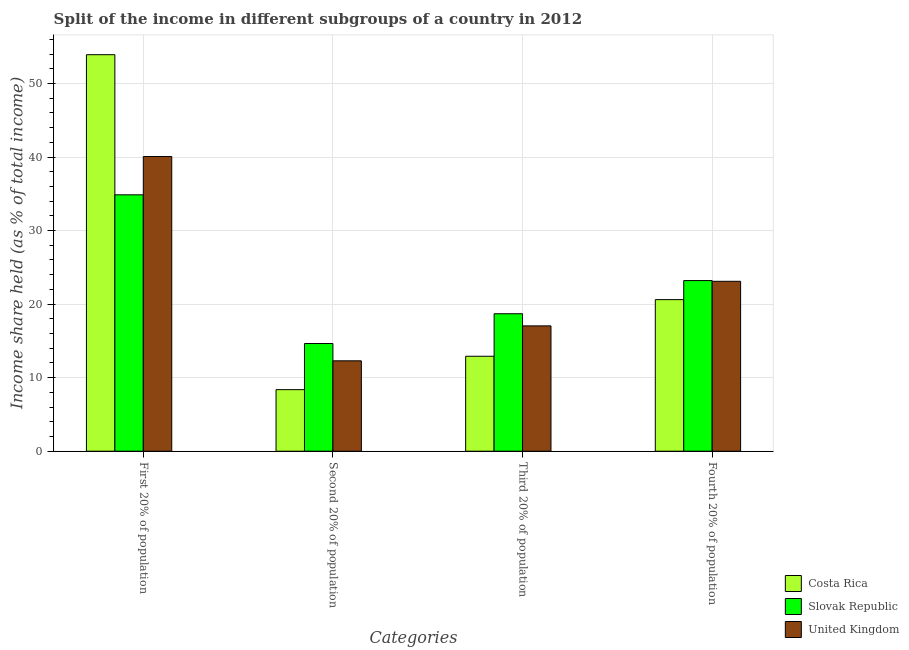How many different coloured bars are there?
Provide a short and direct response. 3. What is the label of the 2nd group of bars from the left?
Your answer should be compact. Second 20% of population. What is the share of the income held by first 20% of the population in Costa Rica?
Your response must be concise. 53.91. Across all countries, what is the maximum share of the income held by third 20% of the population?
Your answer should be very brief. 18.69. Across all countries, what is the minimum share of the income held by first 20% of the population?
Your response must be concise. 34.86. In which country was the share of the income held by third 20% of the population maximum?
Your answer should be compact. Slovak Republic. What is the total share of the income held by second 20% of the population in the graph?
Your response must be concise. 35.3. What is the difference between the share of the income held by first 20% of the population in Slovak Republic and that in Costa Rica?
Your answer should be very brief. -19.05. What is the difference between the share of the income held by second 20% of the population in Costa Rica and the share of the income held by first 20% of the population in United Kingdom?
Ensure brevity in your answer.  -31.7. What is the average share of the income held by second 20% of the population per country?
Your answer should be compact. 11.77. What is the difference between the share of the income held by fourth 20% of the population and share of the income held by first 20% of the population in Costa Rica?
Keep it short and to the point. -33.3. What is the ratio of the share of the income held by first 20% of the population in Slovak Republic to that in United Kingdom?
Keep it short and to the point. 0.87. Is the difference between the share of the income held by fourth 20% of the population in United Kingdom and Slovak Republic greater than the difference between the share of the income held by third 20% of the population in United Kingdom and Slovak Republic?
Ensure brevity in your answer.  Yes. What is the difference between the highest and the second highest share of the income held by fourth 20% of the population?
Your response must be concise. 0.1. What is the difference between the highest and the lowest share of the income held by fourth 20% of the population?
Offer a terse response. 2.59. Is the sum of the share of the income held by fourth 20% of the population in Slovak Republic and United Kingdom greater than the maximum share of the income held by second 20% of the population across all countries?
Offer a terse response. Yes. Is it the case that in every country, the sum of the share of the income held by first 20% of the population and share of the income held by third 20% of the population is greater than the sum of share of the income held by fourth 20% of the population and share of the income held by second 20% of the population?
Offer a terse response. Yes. What does the 2nd bar from the left in Third 20% of population represents?
Your answer should be compact. Slovak Republic. Is it the case that in every country, the sum of the share of the income held by first 20% of the population and share of the income held by second 20% of the population is greater than the share of the income held by third 20% of the population?
Your answer should be compact. Yes. How many bars are there?
Give a very brief answer. 12. Are the values on the major ticks of Y-axis written in scientific E-notation?
Offer a very short reply. No. Where does the legend appear in the graph?
Provide a short and direct response. Bottom right. What is the title of the graph?
Give a very brief answer. Split of the income in different subgroups of a country in 2012. What is the label or title of the X-axis?
Offer a very short reply. Categories. What is the label or title of the Y-axis?
Your answer should be very brief. Income share held (as % of total income). What is the Income share held (as % of total income) in Costa Rica in First 20% of population?
Give a very brief answer. 53.91. What is the Income share held (as % of total income) in Slovak Republic in First 20% of population?
Offer a terse response. 34.86. What is the Income share held (as % of total income) of United Kingdom in First 20% of population?
Give a very brief answer. 40.07. What is the Income share held (as % of total income) of Costa Rica in Second 20% of population?
Your response must be concise. 8.37. What is the Income share held (as % of total income) of Slovak Republic in Second 20% of population?
Keep it short and to the point. 14.64. What is the Income share held (as % of total income) in United Kingdom in Second 20% of population?
Your response must be concise. 12.29. What is the Income share held (as % of total income) of Costa Rica in Third 20% of population?
Ensure brevity in your answer.  12.91. What is the Income share held (as % of total income) in Slovak Republic in Third 20% of population?
Offer a terse response. 18.69. What is the Income share held (as % of total income) in United Kingdom in Third 20% of population?
Provide a succinct answer. 17.04. What is the Income share held (as % of total income) in Costa Rica in Fourth 20% of population?
Make the answer very short. 20.61. What is the Income share held (as % of total income) in Slovak Republic in Fourth 20% of population?
Give a very brief answer. 23.2. What is the Income share held (as % of total income) of United Kingdom in Fourth 20% of population?
Your answer should be compact. 23.1. Across all Categories, what is the maximum Income share held (as % of total income) of Costa Rica?
Provide a succinct answer. 53.91. Across all Categories, what is the maximum Income share held (as % of total income) in Slovak Republic?
Your answer should be very brief. 34.86. Across all Categories, what is the maximum Income share held (as % of total income) of United Kingdom?
Provide a short and direct response. 40.07. Across all Categories, what is the minimum Income share held (as % of total income) of Costa Rica?
Your response must be concise. 8.37. Across all Categories, what is the minimum Income share held (as % of total income) in Slovak Republic?
Provide a succinct answer. 14.64. Across all Categories, what is the minimum Income share held (as % of total income) in United Kingdom?
Your answer should be compact. 12.29. What is the total Income share held (as % of total income) of Costa Rica in the graph?
Your response must be concise. 95.8. What is the total Income share held (as % of total income) of Slovak Republic in the graph?
Ensure brevity in your answer.  91.39. What is the total Income share held (as % of total income) in United Kingdom in the graph?
Your answer should be compact. 92.5. What is the difference between the Income share held (as % of total income) of Costa Rica in First 20% of population and that in Second 20% of population?
Keep it short and to the point. 45.54. What is the difference between the Income share held (as % of total income) of Slovak Republic in First 20% of population and that in Second 20% of population?
Give a very brief answer. 20.22. What is the difference between the Income share held (as % of total income) in United Kingdom in First 20% of population and that in Second 20% of population?
Your answer should be compact. 27.78. What is the difference between the Income share held (as % of total income) of Costa Rica in First 20% of population and that in Third 20% of population?
Keep it short and to the point. 41. What is the difference between the Income share held (as % of total income) in Slovak Republic in First 20% of population and that in Third 20% of population?
Ensure brevity in your answer.  16.17. What is the difference between the Income share held (as % of total income) in United Kingdom in First 20% of population and that in Third 20% of population?
Your answer should be very brief. 23.03. What is the difference between the Income share held (as % of total income) of Costa Rica in First 20% of population and that in Fourth 20% of population?
Ensure brevity in your answer.  33.3. What is the difference between the Income share held (as % of total income) in Slovak Republic in First 20% of population and that in Fourth 20% of population?
Your answer should be compact. 11.66. What is the difference between the Income share held (as % of total income) in United Kingdom in First 20% of population and that in Fourth 20% of population?
Keep it short and to the point. 16.97. What is the difference between the Income share held (as % of total income) in Costa Rica in Second 20% of population and that in Third 20% of population?
Ensure brevity in your answer.  -4.54. What is the difference between the Income share held (as % of total income) of Slovak Republic in Second 20% of population and that in Third 20% of population?
Your response must be concise. -4.05. What is the difference between the Income share held (as % of total income) in United Kingdom in Second 20% of population and that in Third 20% of population?
Keep it short and to the point. -4.75. What is the difference between the Income share held (as % of total income) in Costa Rica in Second 20% of population and that in Fourth 20% of population?
Your answer should be very brief. -12.24. What is the difference between the Income share held (as % of total income) in Slovak Republic in Second 20% of population and that in Fourth 20% of population?
Your answer should be compact. -8.56. What is the difference between the Income share held (as % of total income) in United Kingdom in Second 20% of population and that in Fourth 20% of population?
Offer a terse response. -10.81. What is the difference between the Income share held (as % of total income) of Costa Rica in Third 20% of population and that in Fourth 20% of population?
Your response must be concise. -7.7. What is the difference between the Income share held (as % of total income) of Slovak Republic in Third 20% of population and that in Fourth 20% of population?
Offer a terse response. -4.51. What is the difference between the Income share held (as % of total income) in United Kingdom in Third 20% of population and that in Fourth 20% of population?
Provide a succinct answer. -6.06. What is the difference between the Income share held (as % of total income) of Costa Rica in First 20% of population and the Income share held (as % of total income) of Slovak Republic in Second 20% of population?
Offer a terse response. 39.27. What is the difference between the Income share held (as % of total income) of Costa Rica in First 20% of population and the Income share held (as % of total income) of United Kingdom in Second 20% of population?
Provide a short and direct response. 41.62. What is the difference between the Income share held (as % of total income) of Slovak Republic in First 20% of population and the Income share held (as % of total income) of United Kingdom in Second 20% of population?
Offer a very short reply. 22.57. What is the difference between the Income share held (as % of total income) of Costa Rica in First 20% of population and the Income share held (as % of total income) of Slovak Republic in Third 20% of population?
Your answer should be compact. 35.22. What is the difference between the Income share held (as % of total income) of Costa Rica in First 20% of population and the Income share held (as % of total income) of United Kingdom in Third 20% of population?
Offer a terse response. 36.87. What is the difference between the Income share held (as % of total income) in Slovak Republic in First 20% of population and the Income share held (as % of total income) in United Kingdom in Third 20% of population?
Your answer should be very brief. 17.82. What is the difference between the Income share held (as % of total income) of Costa Rica in First 20% of population and the Income share held (as % of total income) of Slovak Republic in Fourth 20% of population?
Provide a succinct answer. 30.71. What is the difference between the Income share held (as % of total income) of Costa Rica in First 20% of population and the Income share held (as % of total income) of United Kingdom in Fourth 20% of population?
Ensure brevity in your answer.  30.81. What is the difference between the Income share held (as % of total income) in Slovak Republic in First 20% of population and the Income share held (as % of total income) in United Kingdom in Fourth 20% of population?
Offer a terse response. 11.76. What is the difference between the Income share held (as % of total income) of Costa Rica in Second 20% of population and the Income share held (as % of total income) of Slovak Republic in Third 20% of population?
Offer a very short reply. -10.32. What is the difference between the Income share held (as % of total income) of Costa Rica in Second 20% of population and the Income share held (as % of total income) of United Kingdom in Third 20% of population?
Provide a succinct answer. -8.67. What is the difference between the Income share held (as % of total income) of Slovak Republic in Second 20% of population and the Income share held (as % of total income) of United Kingdom in Third 20% of population?
Make the answer very short. -2.4. What is the difference between the Income share held (as % of total income) of Costa Rica in Second 20% of population and the Income share held (as % of total income) of Slovak Republic in Fourth 20% of population?
Ensure brevity in your answer.  -14.83. What is the difference between the Income share held (as % of total income) of Costa Rica in Second 20% of population and the Income share held (as % of total income) of United Kingdom in Fourth 20% of population?
Make the answer very short. -14.73. What is the difference between the Income share held (as % of total income) in Slovak Republic in Second 20% of population and the Income share held (as % of total income) in United Kingdom in Fourth 20% of population?
Keep it short and to the point. -8.46. What is the difference between the Income share held (as % of total income) of Costa Rica in Third 20% of population and the Income share held (as % of total income) of Slovak Republic in Fourth 20% of population?
Make the answer very short. -10.29. What is the difference between the Income share held (as % of total income) in Costa Rica in Third 20% of population and the Income share held (as % of total income) in United Kingdom in Fourth 20% of population?
Your response must be concise. -10.19. What is the difference between the Income share held (as % of total income) in Slovak Republic in Third 20% of population and the Income share held (as % of total income) in United Kingdom in Fourth 20% of population?
Offer a terse response. -4.41. What is the average Income share held (as % of total income) of Costa Rica per Categories?
Your answer should be very brief. 23.95. What is the average Income share held (as % of total income) in Slovak Republic per Categories?
Offer a very short reply. 22.85. What is the average Income share held (as % of total income) in United Kingdom per Categories?
Your answer should be very brief. 23.12. What is the difference between the Income share held (as % of total income) of Costa Rica and Income share held (as % of total income) of Slovak Republic in First 20% of population?
Give a very brief answer. 19.05. What is the difference between the Income share held (as % of total income) of Costa Rica and Income share held (as % of total income) of United Kingdom in First 20% of population?
Give a very brief answer. 13.84. What is the difference between the Income share held (as % of total income) in Slovak Republic and Income share held (as % of total income) in United Kingdom in First 20% of population?
Provide a short and direct response. -5.21. What is the difference between the Income share held (as % of total income) in Costa Rica and Income share held (as % of total income) in Slovak Republic in Second 20% of population?
Make the answer very short. -6.27. What is the difference between the Income share held (as % of total income) in Costa Rica and Income share held (as % of total income) in United Kingdom in Second 20% of population?
Your response must be concise. -3.92. What is the difference between the Income share held (as % of total income) of Slovak Republic and Income share held (as % of total income) of United Kingdom in Second 20% of population?
Offer a very short reply. 2.35. What is the difference between the Income share held (as % of total income) of Costa Rica and Income share held (as % of total income) of Slovak Republic in Third 20% of population?
Give a very brief answer. -5.78. What is the difference between the Income share held (as % of total income) in Costa Rica and Income share held (as % of total income) in United Kingdom in Third 20% of population?
Provide a succinct answer. -4.13. What is the difference between the Income share held (as % of total income) of Slovak Republic and Income share held (as % of total income) of United Kingdom in Third 20% of population?
Make the answer very short. 1.65. What is the difference between the Income share held (as % of total income) of Costa Rica and Income share held (as % of total income) of Slovak Republic in Fourth 20% of population?
Your response must be concise. -2.59. What is the difference between the Income share held (as % of total income) in Costa Rica and Income share held (as % of total income) in United Kingdom in Fourth 20% of population?
Offer a terse response. -2.49. What is the ratio of the Income share held (as % of total income) of Costa Rica in First 20% of population to that in Second 20% of population?
Provide a short and direct response. 6.44. What is the ratio of the Income share held (as % of total income) of Slovak Republic in First 20% of population to that in Second 20% of population?
Offer a very short reply. 2.38. What is the ratio of the Income share held (as % of total income) of United Kingdom in First 20% of population to that in Second 20% of population?
Your response must be concise. 3.26. What is the ratio of the Income share held (as % of total income) of Costa Rica in First 20% of population to that in Third 20% of population?
Provide a succinct answer. 4.18. What is the ratio of the Income share held (as % of total income) in Slovak Republic in First 20% of population to that in Third 20% of population?
Provide a succinct answer. 1.87. What is the ratio of the Income share held (as % of total income) in United Kingdom in First 20% of population to that in Third 20% of population?
Give a very brief answer. 2.35. What is the ratio of the Income share held (as % of total income) in Costa Rica in First 20% of population to that in Fourth 20% of population?
Offer a terse response. 2.62. What is the ratio of the Income share held (as % of total income) of Slovak Republic in First 20% of population to that in Fourth 20% of population?
Your answer should be compact. 1.5. What is the ratio of the Income share held (as % of total income) in United Kingdom in First 20% of population to that in Fourth 20% of population?
Provide a short and direct response. 1.73. What is the ratio of the Income share held (as % of total income) of Costa Rica in Second 20% of population to that in Third 20% of population?
Provide a succinct answer. 0.65. What is the ratio of the Income share held (as % of total income) in Slovak Republic in Second 20% of population to that in Third 20% of population?
Ensure brevity in your answer.  0.78. What is the ratio of the Income share held (as % of total income) in United Kingdom in Second 20% of population to that in Third 20% of population?
Keep it short and to the point. 0.72. What is the ratio of the Income share held (as % of total income) in Costa Rica in Second 20% of population to that in Fourth 20% of population?
Offer a very short reply. 0.41. What is the ratio of the Income share held (as % of total income) in Slovak Republic in Second 20% of population to that in Fourth 20% of population?
Your answer should be compact. 0.63. What is the ratio of the Income share held (as % of total income) of United Kingdom in Second 20% of population to that in Fourth 20% of population?
Your response must be concise. 0.53. What is the ratio of the Income share held (as % of total income) in Costa Rica in Third 20% of population to that in Fourth 20% of population?
Your answer should be compact. 0.63. What is the ratio of the Income share held (as % of total income) of Slovak Republic in Third 20% of population to that in Fourth 20% of population?
Your response must be concise. 0.81. What is the ratio of the Income share held (as % of total income) in United Kingdom in Third 20% of population to that in Fourth 20% of population?
Offer a very short reply. 0.74. What is the difference between the highest and the second highest Income share held (as % of total income) of Costa Rica?
Give a very brief answer. 33.3. What is the difference between the highest and the second highest Income share held (as % of total income) in Slovak Republic?
Offer a terse response. 11.66. What is the difference between the highest and the second highest Income share held (as % of total income) of United Kingdom?
Your answer should be compact. 16.97. What is the difference between the highest and the lowest Income share held (as % of total income) of Costa Rica?
Offer a very short reply. 45.54. What is the difference between the highest and the lowest Income share held (as % of total income) of Slovak Republic?
Your answer should be compact. 20.22. What is the difference between the highest and the lowest Income share held (as % of total income) in United Kingdom?
Keep it short and to the point. 27.78. 